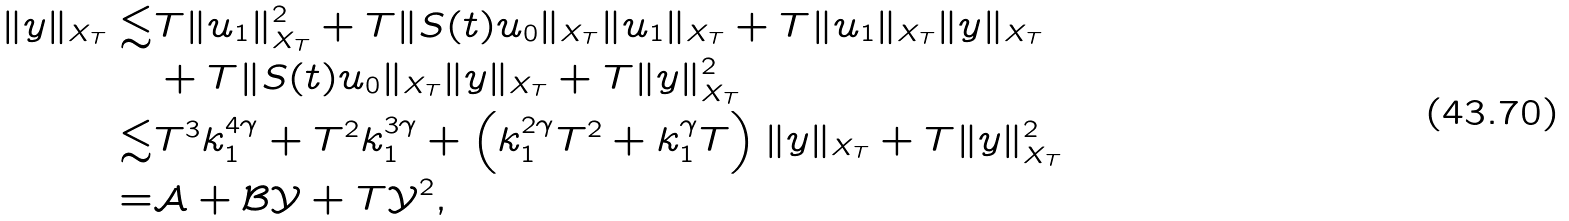Convert formula to latex. <formula><loc_0><loc_0><loc_500><loc_500>\| y \| _ { X _ { T } } \lesssim & T \| u _ { 1 } \| _ { X _ { T } } ^ { 2 } + T \| S ( t ) u _ { 0 } \| _ { X _ { T } } \| u _ { 1 } \| _ { X _ { T } } + T \| u _ { 1 } \| _ { X _ { T } } \| y \| _ { X _ { T } } \\ & + T \| S ( t ) u _ { 0 } \| _ { X _ { T } } \| y \| _ { X _ { T } } + T \| y \| _ { X _ { T } } ^ { 2 } \\ \lesssim & T ^ { 3 } k _ { 1 } ^ { 4 \gamma } + T ^ { 2 } k _ { 1 } ^ { 3 \gamma } + \left ( k _ { 1 } ^ { 2 \gamma } T ^ { 2 } + k _ { 1 } ^ { \gamma } T \right ) \| y \| _ { X _ { T } } + T \| y \| _ { X _ { T } } ^ { 2 } \\ = & \mathcal { A } + \mathcal { B } \mathcal { Y } + T \mathcal { Y } ^ { 2 } ,</formula> 